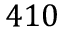Convert formula to latex. <formula><loc_0><loc_0><loc_500><loc_500>4 1 0</formula> 